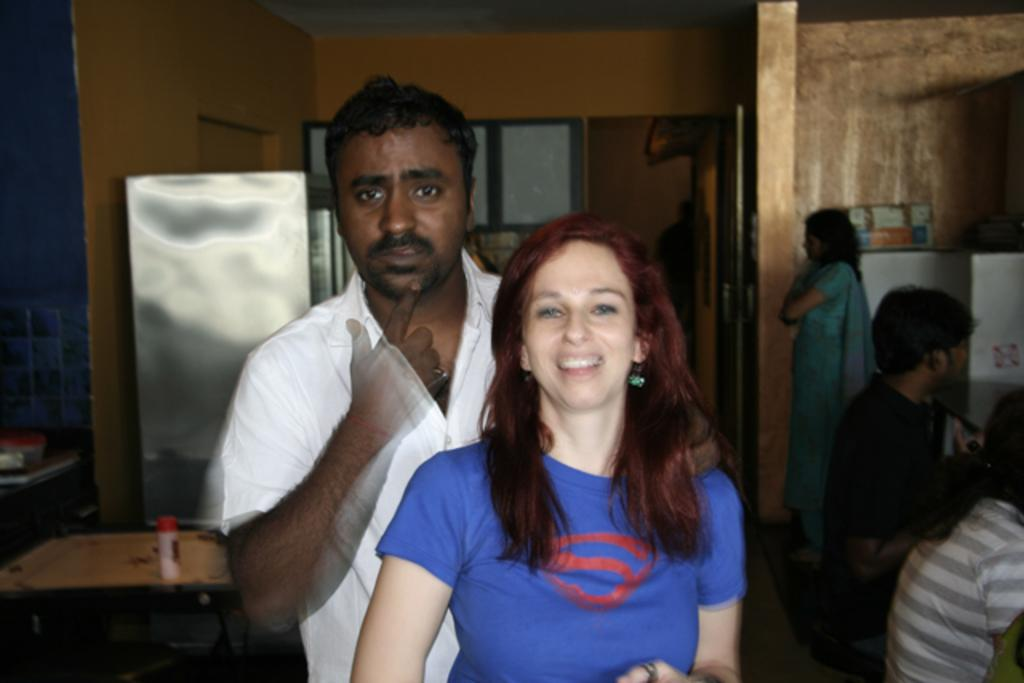How many people are present in the image? There are two people, a man and a woman, present in the image. What are the man and woman doing in the image? The man and woman are standing. Can you describe the background of the image? In the background of the image, there are two persons sitting, a woman standing, a table, and a door. What might be the purpose of the table in the background? The table in the background might be used for placing objects or serving food. What type of stick can be seen in the hand of the woman in the image? There is no stick present in the image; the woman is not holding anything. 